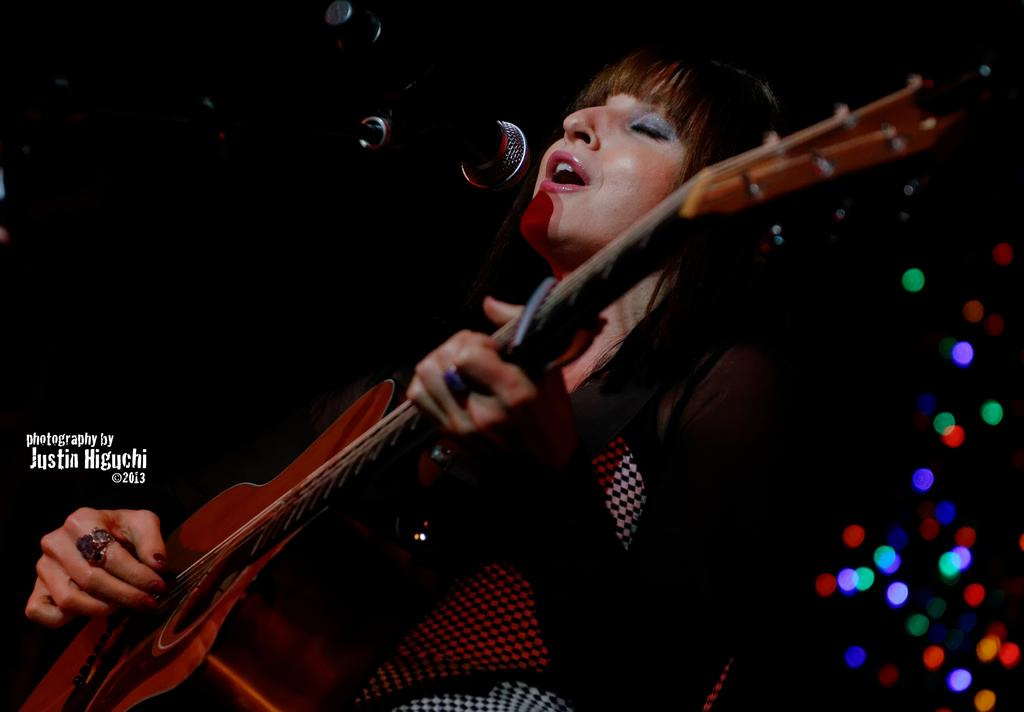What is the woman in the image doing? The woman is singing and playing a guitar. What is the woman wearing in the image? The woman is wearing a black dress. What object is in front of the woman? There is a microphone in front of the woman. How can you describe the background of the image? The background of the image is dark. Can you tell me how many hens are present in the image? There are no hens present in the image; it features a woman singing and playing a guitar. What type of writer is depicted in the image? There is no writer depicted in the image; it features a woman singing and playing a guitar. 